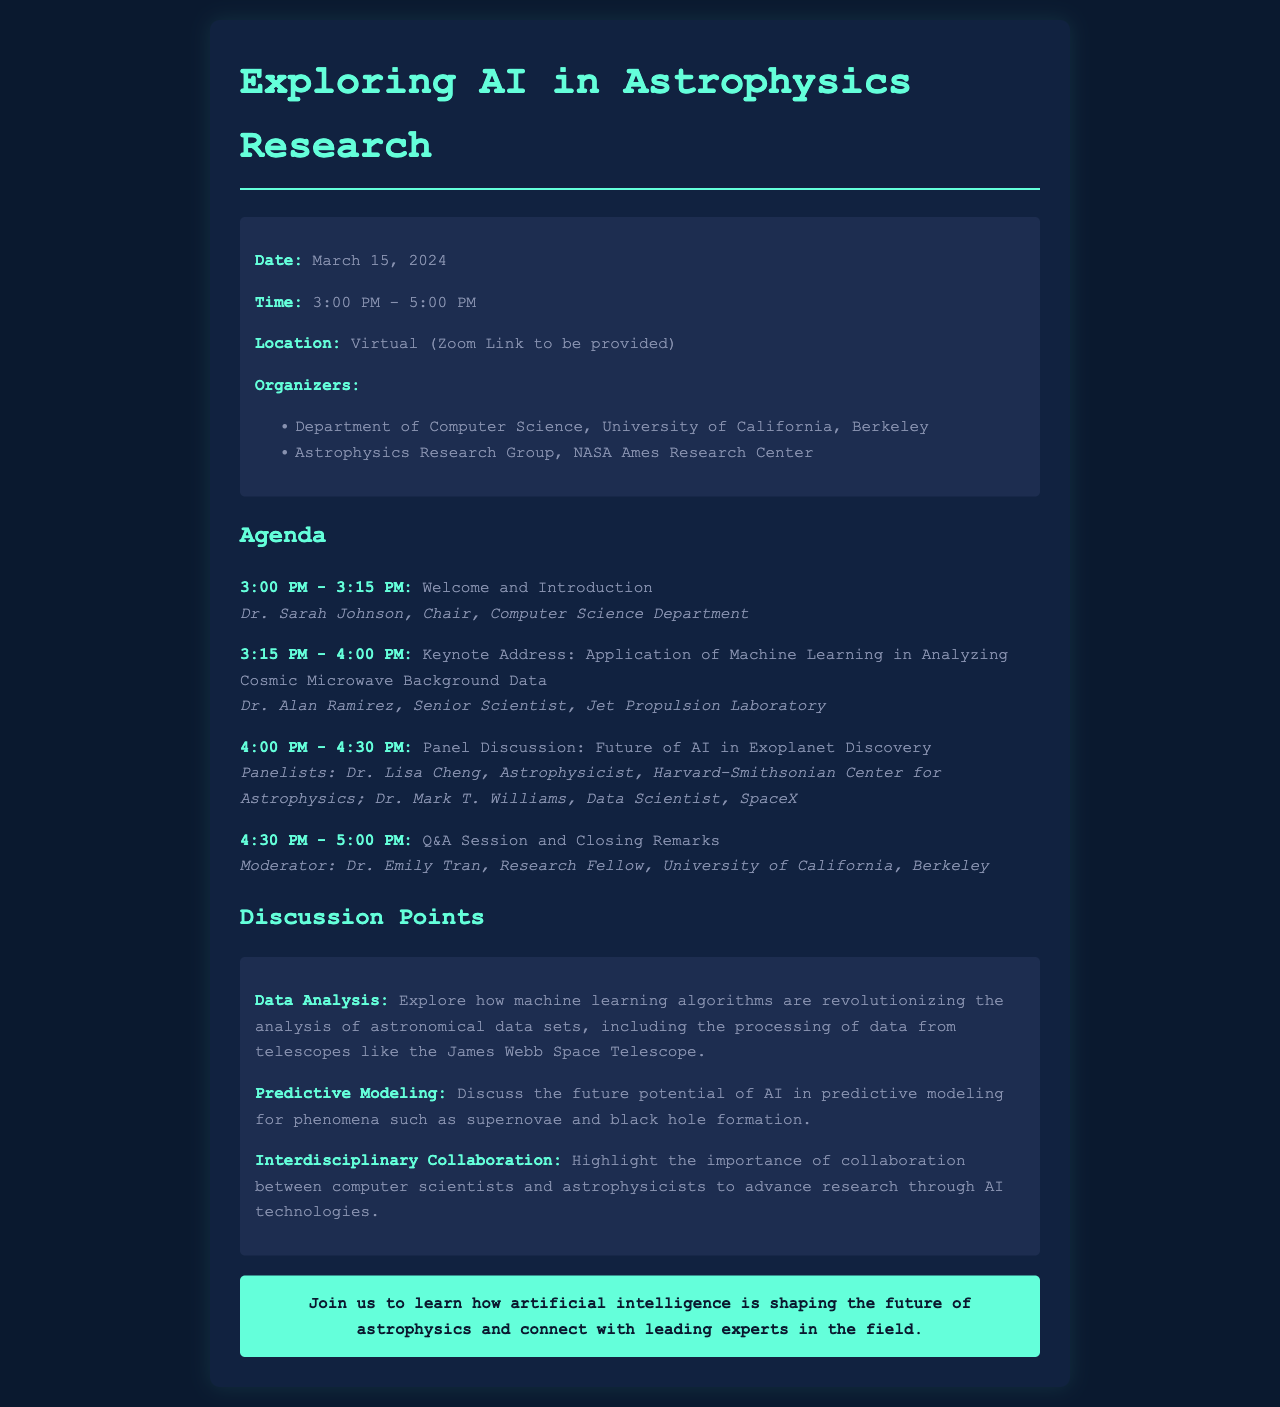What is the date of the seminar? The date of the seminar is explicitly mentioned in the document as March 15, 2024.
Answer: March 15, 2024 What time does the seminar start? The seminar's starting time is stated in the document as 3:00 PM.
Answer: 3:00 PM Who is giving the keynote address? The document lists Dr. Alan Ramirez as the speaker for the keynote address.
Answer: Dr. Alan Ramirez What is the main topic of the keynote address? The document states that the keynote address will discuss the application of machine learning in analyzing cosmic microwave background data.
Answer: Application of Machine Learning in Analyzing Cosmic Microwave Background Data How long is the panel discussion? The document specifies that the panel discussion is from 4:00 PM to 4:30 PM, making it 30 minutes long.
Answer: 30 minutes What are the names of the panelists? The document includes Dr. Lisa Cheng and Dr. Mark T. Williams as the panelists.
Answer: Dr. Lisa Cheng and Dr. Mark T. Williams What will be discussed regarding interdisciplinary collaboration? The document notes that the discussion will highlight the importance of collaboration between computer scientists and astrophysicists.
Answer: Importance of collaboration between computer scientists and astrophysicists What is one of the discussion points related to data analysis? The document mentions that machine learning algorithms are revolutionizing the analysis of astronomical data sets.
Answer: Machine learning algorithms are revolutionizing the analysis of astronomical data sets What is the conclusion's focus in the call to action? The conclusion emphasizes learning how artificial intelligence is shaping the future of astrophysics.
Answer: How artificial intelligence is shaping the future of astrophysics 